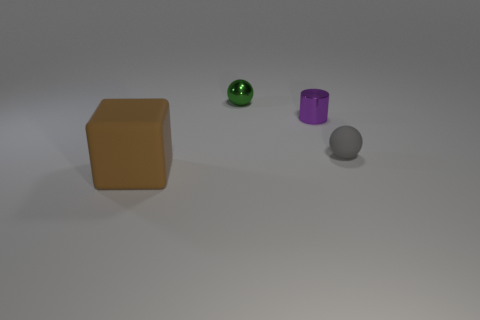Do the gray rubber thing and the shiny cylinder have the same size?
Keep it short and to the point. Yes. What number of objects are gray matte balls or blue spheres?
Your answer should be very brief. 1. What is the size of the matte object that is to the left of the sphere that is on the right side of the green thing?
Provide a succinct answer. Large. What size is the green sphere?
Your answer should be compact. Small. What shape is the small object that is right of the green ball and on the left side of the small gray thing?
Your response must be concise. Cylinder. The other thing that is the same shape as the small green shiny thing is what color?
Offer a terse response. Gray. How many objects are either objects that are on the right side of the large matte cube or rubber objects that are right of the matte block?
Offer a terse response. 3. The large brown matte object has what shape?
Your response must be concise. Cube. How many large brown objects are the same material as the gray sphere?
Make the answer very short. 1. The large rubber block has what color?
Keep it short and to the point. Brown. 